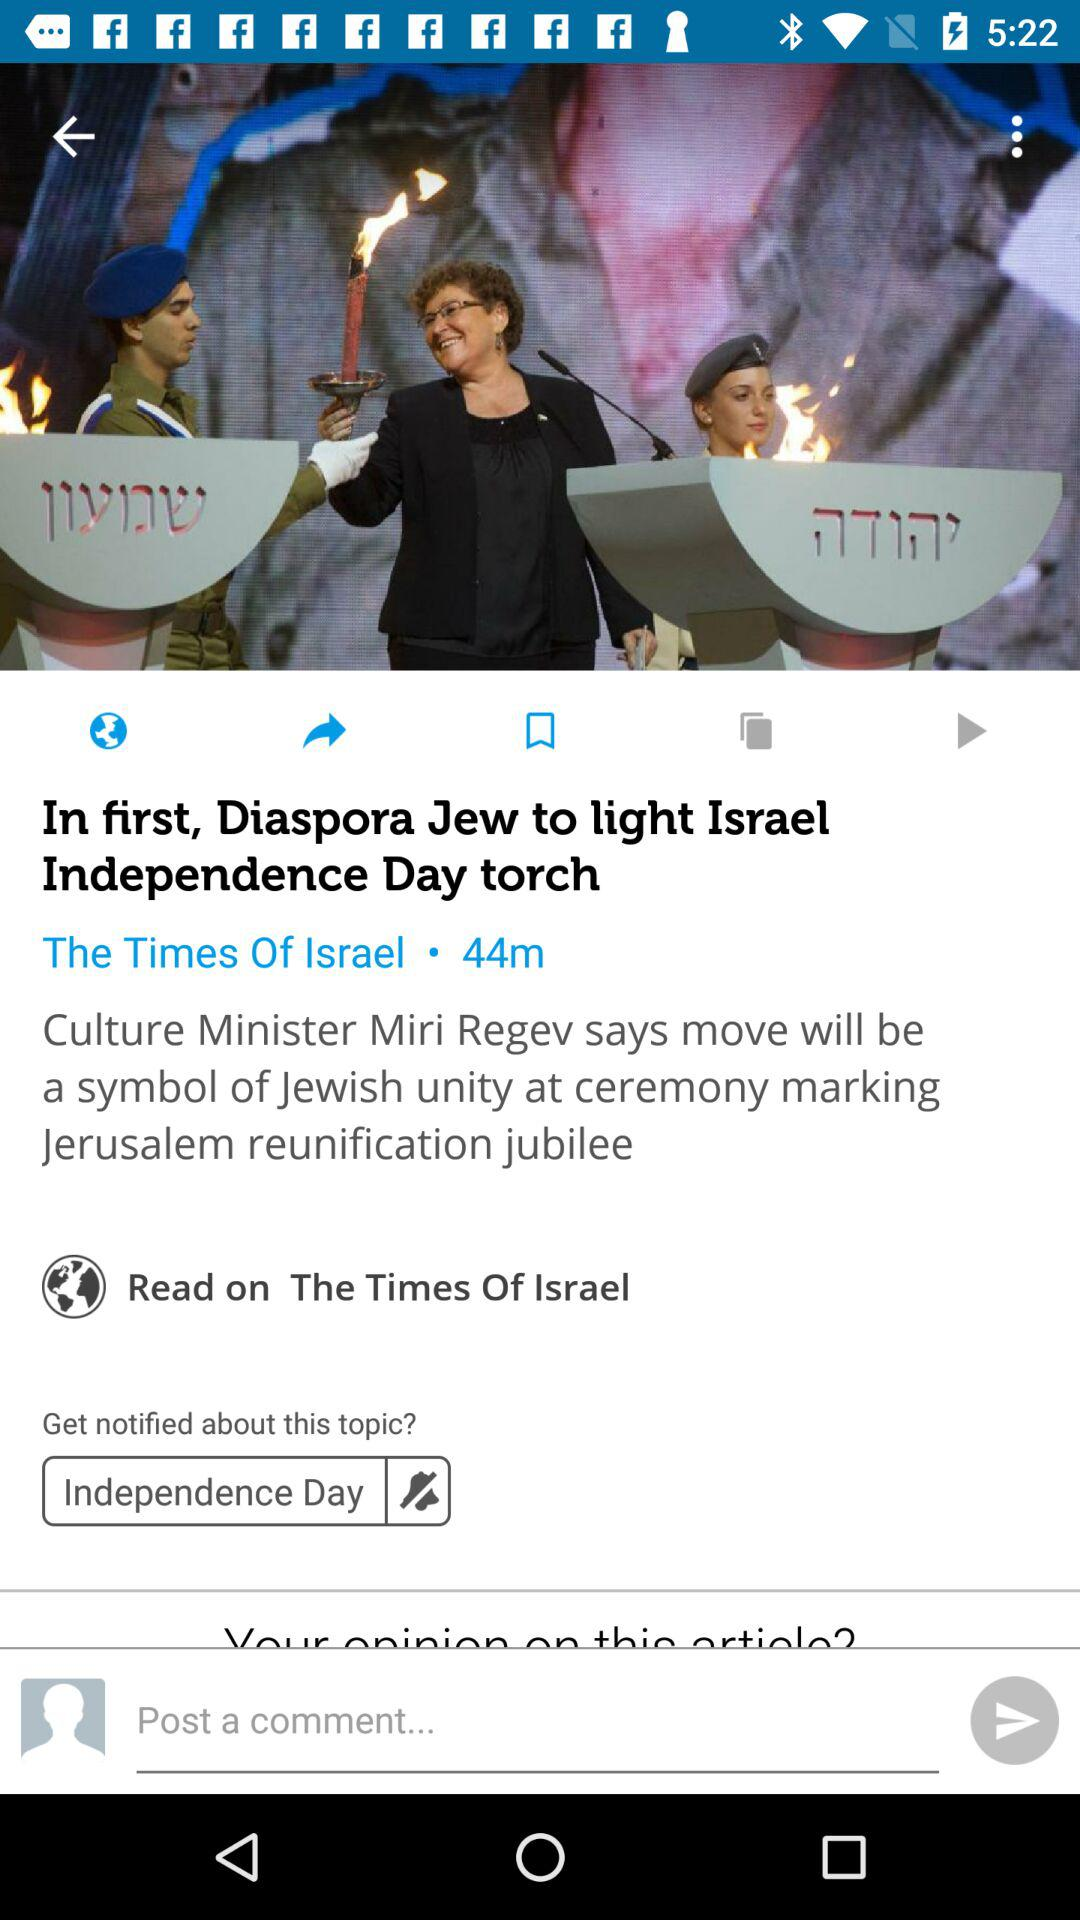What is the title of the news? The title of the news is "In first, Diaspora Jew to light Israel Independence Day torch". 